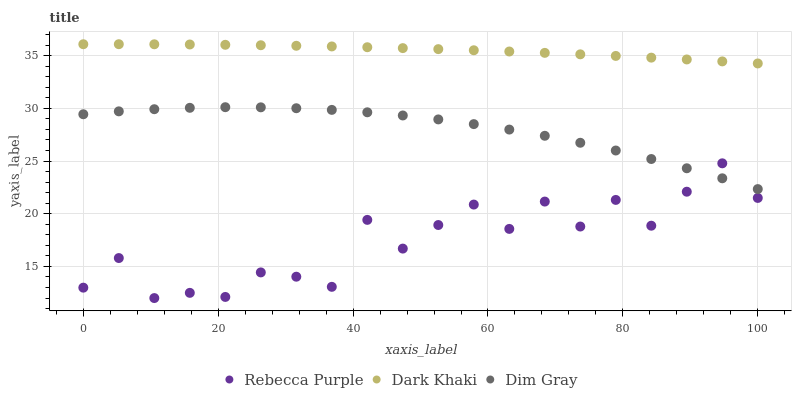Does Rebecca Purple have the minimum area under the curve?
Answer yes or no. Yes. Does Dark Khaki have the maximum area under the curve?
Answer yes or no. Yes. Does Dim Gray have the minimum area under the curve?
Answer yes or no. No. Does Dim Gray have the maximum area under the curve?
Answer yes or no. No. Is Dark Khaki the smoothest?
Answer yes or no. Yes. Is Rebecca Purple the roughest?
Answer yes or no. Yes. Is Dim Gray the smoothest?
Answer yes or no. No. Is Dim Gray the roughest?
Answer yes or no. No. Does Rebecca Purple have the lowest value?
Answer yes or no. Yes. Does Dim Gray have the lowest value?
Answer yes or no. No. Does Dark Khaki have the highest value?
Answer yes or no. Yes. Does Dim Gray have the highest value?
Answer yes or no. No. Is Dim Gray less than Dark Khaki?
Answer yes or no. Yes. Is Dark Khaki greater than Dim Gray?
Answer yes or no. Yes. Does Rebecca Purple intersect Dim Gray?
Answer yes or no. Yes. Is Rebecca Purple less than Dim Gray?
Answer yes or no. No. Is Rebecca Purple greater than Dim Gray?
Answer yes or no. No. Does Dim Gray intersect Dark Khaki?
Answer yes or no. No. 